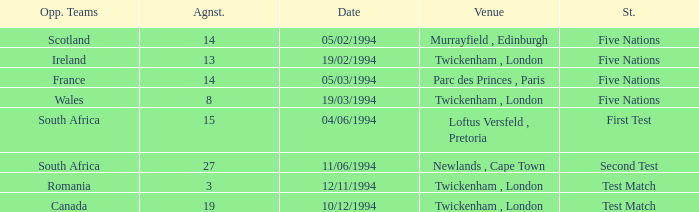How many against have a status of first test? 1.0. 